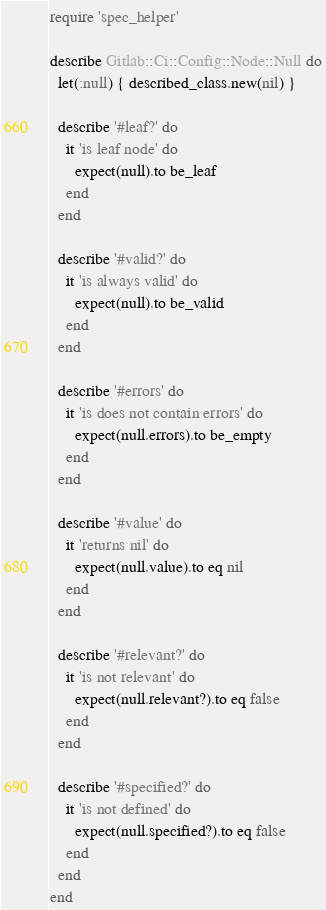Convert code to text. <code><loc_0><loc_0><loc_500><loc_500><_Ruby_>require 'spec_helper'

describe Gitlab::Ci::Config::Node::Null do
  let(:null) { described_class.new(nil) }

  describe '#leaf?' do
    it 'is leaf node' do
      expect(null).to be_leaf
    end
  end

  describe '#valid?' do
    it 'is always valid' do
      expect(null).to be_valid
    end
  end

  describe '#errors' do
    it 'is does not contain errors' do
      expect(null.errors).to be_empty
    end
  end

  describe '#value' do
    it 'returns nil' do
      expect(null.value).to eq nil
    end
  end

  describe '#relevant?' do
    it 'is not relevant' do
      expect(null.relevant?).to eq false
    end
  end

  describe '#specified?' do
    it 'is not defined' do
      expect(null.specified?).to eq false
    end
  end
end
</code> 